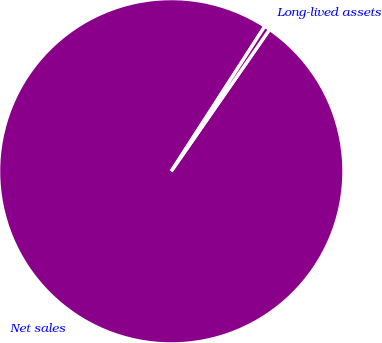Convert chart to OTSL. <chart><loc_0><loc_0><loc_500><loc_500><pie_chart><fcel>Net sales<fcel>Long-lived assets<nl><fcel>99.47%<fcel>0.53%<nl></chart> 